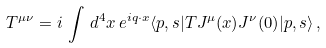<formula> <loc_0><loc_0><loc_500><loc_500>T ^ { \mu \nu } = i \, \int \, d ^ { 4 } x \, e ^ { i q \cdot x } \langle { p , s } | { T J ^ { \mu } ( x ) J ^ { \nu } ( 0 ) } | { p , s } \rangle \, ,</formula> 